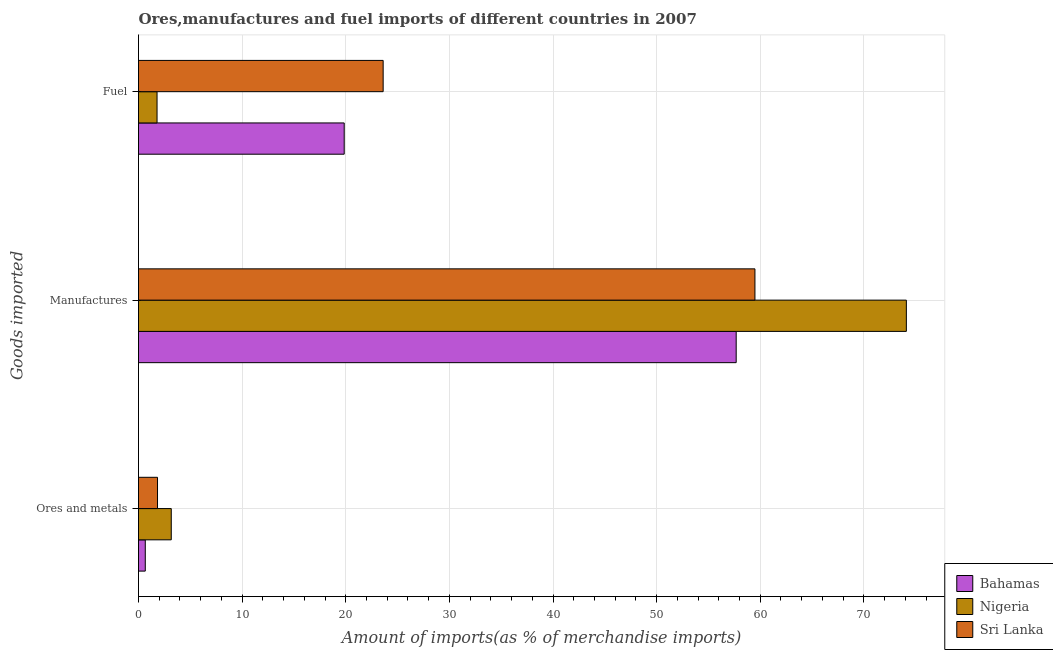How many different coloured bars are there?
Give a very brief answer. 3. Are the number of bars per tick equal to the number of legend labels?
Make the answer very short. Yes. Are the number of bars on each tick of the Y-axis equal?
Make the answer very short. Yes. How many bars are there on the 1st tick from the bottom?
Provide a succinct answer. 3. What is the label of the 1st group of bars from the top?
Make the answer very short. Fuel. What is the percentage of ores and metals imports in Nigeria?
Give a very brief answer. 3.16. Across all countries, what is the maximum percentage of manufactures imports?
Your answer should be compact. 74.1. Across all countries, what is the minimum percentage of fuel imports?
Offer a terse response. 1.79. In which country was the percentage of fuel imports maximum?
Your answer should be very brief. Sri Lanka. In which country was the percentage of fuel imports minimum?
Offer a very short reply. Nigeria. What is the total percentage of ores and metals imports in the graph?
Keep it short and to the point. 5.65. What is the difference between the percentage of ores and metals imports in Bahamas and that in Nigeria?
Your answer should be compact. -2.51. What is the difference between the percentage of manufactures imports in Sri Lanka and the percentage of fuel imports in Bahamas?
Your response must be concise. 39.64. What is the average percentage of manufactures imports per country?
Offer a terse response. 63.76. What is the difference between the percentage of manufactures imports and percentage of fuel imports in Sri Lanka?
Ensure brevity in your answer.  35.88. In how many countries, is the percentage of fuel imports greater than 60 %?
Offer a very short reply. 0. What is the ratio of the percentage of manufactures imports in Bahamas to that in Sri Lanka?
Make the answer very short. 0.97. Is the difference between the percentage of ores and metals imports in Sri Lanka and Bahamas greater than the difference between the percentage of fuel imports in Sri Lanka and Bahamas?
Give a very brief answer. No. What is the difference between the highest and the second highest percentage of ores and metals imports?
Give a very brief answer. 1.33. What is the difference between the highest and the lowest percentage of fuel imports?
Make the answer very short. 21.82. What does the 2nd bar from the top in Ores and metals represents?
Offer a terse response. Nigeria. What does the 2nd bar from the bottom in Ores and metals represents?
Ensure brevity in your answer.  Nigeria. Is it the case that in every country, the sum of the percentage of ores and metals imports and percentage of manufactures imports is greater than the percentage of fuel imports?
Offer a very short reply. Yes. How many bars are there?
Give a very brief answer. 9. Does the graph contain any zero values?
Offer a very short reply. No. Does the graph contain grids?
Ensure brevity in your answer.  Yes. Where does the legend appear in the graph?
Keep it short and to the point. Bottom right. How many legend labels are there?
Keep it short and to the point. 3. What is the title of the graph?
Your answer should be very brief. Ores,manufactures and fuel imports of different countries in 2007. What is the label or title of the X-axis?
Ensure brevity in your answer.  Amount of imports(as % of merchandise imports). What is the label or title of the Y-axis?
Your answer should be very brief. Goods imported. What is the Amount of imports(as % of merchandise imports) of Bahamas in Ores and metals?
Make the answer very short. 0.65. What is the Amount of imports(as % of merchandise imports) in Nigeria in Ores and metals?
Your answer should be compact. 3.16. What is the Amount of imports(as % of merchandise imports) in Sri Lanka in Ores and metals?
Keep it short and to the point. 1.83. What is the Amount of imports(as % of merchandise imports) in Bahamas in Manufactures?
Keep it short and to the point. 57.68. What is the Amount of imports(as % of merchandise imports) of Nigeria in Manufactures?
Ensure brevity in your answer.  74.1. What is the Amount of imports(as % of merchandise imports) in Sri Lanka in Manufactures?
Provide a short and direct response. 59.49. What is the Amount of imports(as % of merchandise imports) in Bahamas in Fuel?
Your response must be concise. 19.85. What is the Amount of imports(as % of merchandise imports) in Nigeria in Fuel?
Give a very brief answer. 1.79. What is the Amount of imports(as % of merchandise imports) in Sri Lanka in Fuel?
Give a very brief answer. 23.61. Across all Goods imported, what is the maximum Amount of imports(as % of merchandise imports) of Bahamas?
Provide a succinct answer. 57.68. Across all Goods imported, what is the maximum Amount of imports(as % of merchandise imports) of Nigeria?
Keep it short and to the point. 74.1. Across all Goods imported, what is the maximum Amount of imports(as % of merchandise imports) of Sri Lanka?
Offer a very short reply. 59.49. Across all Goods imported, what is the minimum Amount of imports(as % of merchandise imports) in Bahamas?
Offer a terse response. 0.65. Across all Goods imported, what is the minimum Amount of imports(as % of merchandise imports) of Nigeria?
Offer a very short reply. 1.79. Across all Goods imported, what is the minimum Amount of imports(as % of merchandise imports) in Sri Lanka?
Make the answer very short. 1.83. What is the total Amount of imports(as % of merchandise imports) in Bahamas in the graph?
Provide a succinct answer. 78.18. What is the total Amount of imports(as % of merchandise imports) of Nigeria in the graph?
Ensure brevity in your answer.  79.05. What is the total Amount of imports(as % of merchandise imports) of Sri Lanka in the graph?
Provide a short and direct response. 84.93. What is the difference between the Amount of imports(as % of merchandise imports) of Bahamas in Ores and metals and that in Manufactures?
Your answer should be very brief. -57.02. What is the difference between the Amount of imports(as % of merchandise imports) in Nigeria in Ores and metals and that in Manufactures?
Make the answer very short. -70.94. What is the difference between the Amount of imports(as % of merchandise imports) in Sri Lanka in Ores and metals and that in Manufactures?
Make the answer very short. -57.65. What is the difference between the Amount of imports(as % of merchandise imports) in Bahamas in Ores and metals and that in Fuel?
Your answer should be very brief. -19.2. What is the difference between the Amount of imports(as % of merchandise imports) in Nigeria in Ores and metals and that in Fuel?
Ensure brevity in your answer.  1.37. What is the difference between the Amount of imports(as % of merchandise imports) of Sri Lanka in Ores and metals and that in Fuel?
Offer a very short reply. -21.77. What is the difference between the Amount of imports(as % of merchandise imports) in Bahamas in Manufactures and that in Fuel?
Offer a very short reply. 37.83. What is the difference between the Amount of imports(as % of merchandise imports) of Nigeria in Manufactures and that in Fuel?
Your response must be concise. 72.31. What is the difference between the Amount of imports(as % of merchandise imports) of Sri Lanka in Manufactures and that in Fuel?
Provide a succinct answer. 35.88. What is the difference between the Amount of imports(as % of merchandise imports) of Bahamas in Ores and metals and the Amount of imports(as % of merchandise imports) of Nigeria in Manufactures?
Provide a succinct answer. -73.45. What is the difference between the Amount of imports(as % of merchandise imports) in Bahamas in Ores and metals and the Amount of imports(as % of merchandise imports) in Sri Lanka in Manufactures?
Keep it short and to the point. -58.83. What is the difference between the Amount of imports(as % of merchandise imports) of Nigeria in Ores and metals and the Amount of imports(as % of merchandise imports) of Sri Lanka in Manufactures?
Ensure brevity in your answer.  -56.33. What is the difference between the Amount of imports(as % of merchandise imports) in Bahamas in Ores and metals and the Amount of imports(as % of merchandise imports) in Nigeria in Fuel?
Your answer should be very brief. -1.14. What is the difference between the Amount of imports(as % of merchandise imports) of Bahamas in Ores and metals and the Amount of imports(as % of merchandise imports) of Sri Lanka in Fuel?
Make the answer very short. -22.95. What is the difference between the Amount of imports(as % of merchandise imports) in Nigeria in Ores and metals and the Amount of imports(as % of merchandise imports) in Sri Lanka in Fuel?
Keep it short and to the point. -20.45. What is the difference between the Amount of imports(as % of merchandise imports) in Bahamas in Manufactures and the Amount of imports(as % of merchandise imports) in Nigeria in Fuel?
Your answer should be compact. 55.89. What is the difference between the Amount of imports(as % of merchandise imports) in Bahamas in Manufactures and the Amount of imports(as % of merchandise imports) in Sri Lanka in Fuel?
Ensure brevity in your answer.  34.07. What is the difference between the Amount of imports(as % of merchandise imports) in Nigeria in Manufactures and the Amount of imports(as % of merchandise imports) in Sri Lanka in Fuel?
Offer a very short reply. 50.49. What is the average Amount of imports(as % of merchandise imports) in Bahamas per Goods imported?
Keep it short and to the point. 26.06. What is the average Amount of imports(as % of merchandise imports) of Nigeria per Goods imported?
Your answer should be very brief. 26.35. What is the average Amount of imports(as % of merchandise imports) in Sri Lanka per Goods imported?
Ensure brevity in your answer.  28.31. What is the difference between the Amount of imports(as % of merchandise imports) in Bahamas and Amount of imports(as % of merchandise imports) in Nigeria in Ores and metals?
Provide a short and direct response. -2.51. What is the difference between the Amount of imports(as % of merchandise imports) in Bahamas and Amount of imports(as % of merchandise imports) in Sri Lanka in Ores and metals?
Give a very brief answer. -1.18. What is the difference between the Amount of imports(as % of merchandise imports) in Nigeria and Amount of imports(as % of merchandise imports) in Sri Lanka in Ores and metals?
Give a very brief answer. 1.33. What is the difference between the Amount of imports(as % of merchandise imports) of Bahamas and Amount of imports(as % of merchandise imports) of Nigeria in Manufactures?
Ensure brevity in your answer.  -16.42. What is the difference between the Amount of imports(as % of merchandise imports) of Bahamas and Amount of imports(as % of merchandise imports) of Sri Lanka in Manufactures?
Provide a succinct answer. -1.81. What is the difference between the Amount of imports(as % of merchandise imports) in Nigeria and Amount of imports(as % of merchandise imports) in Sri Lanka in Manufactures?
Offer a terse response. 14.61. What is the difference between the Amount of imports(as % of merchandise imports) of Bahamas and Amount of imports(as % of merchandise imports) of Nigeria in Fuel?
Your answer should be very brief. 18.06. What is the difference between the Amount of imports(as % of merchandise imports) of Bahamas and Amount of imports(as % of merchandise imports) of Sri Lanka in Fuel?
Make the answer very short. -3.76. What is the difference between the Amount of imports(as % of merchandise imports) in Nigeria and Amount of imports(as % of merchandise imports) in Sri Lanka in Fuel?
Your answer should be compact. -21.82. What is the ratio of the Amount of imports(as % of merchandise imports) in Bahamas in Ores and metals to that in Manufactures?
Provide a short and direct response. 0.01. What is the ratio of the Amount of imports(as % of merchandise imports) in Nigeria in Ores and metals to that in Manufactures?
Offer a very short reply. 0.04. What is the ratio of the Amount of imports(as % of merchandise imports) in Sri Lanka in Ores and metals to that in Manufactures?
Make the answer very short. 0.03. What is the ratio of the Amount of imports(as % of merchandise imports) of Bahamas in Ores and metals to that in Fuel?
Provide a short and direct response. 0.03. What is the ratio of the Amount of imports(as % of merchandise imports) in Nigeria in Ores and metals to that in Fuel?
Ensure brevity in your answer.  1.77. What is the ratio of the Amount of imports(as % of merchandise imports) in Sri Lanka in Ores and metals to that in Fuel?
Give a very brief answer. 0.08. What is the ratio of the Amount of imports(as % of merchandise imports) in Bahamas in Manufactures to that in Fuel?
Offer a very short reply. 2.91. What is the ratio of the Amount of imports(as % of merchandise imports) in Nigeria in Manufactures to that in Fuel?
Keep it short and to the point. 41.4. What is the ratio of the Amount of imports(as % of merchandise imports) in Sri Lanka in Manufactures to that in Fuel?
Your answer should be compact. 2.52. What is the difference between the highest and the second highest Amount of imports(as % of merchandise imports) of Bahamas?
Keep it short and to the point. 37.83. What is the difference between the highest and the second highest Amount of imports(as % of merchandise imports) in Nigeria?
Give a very brief answer. 70.94. What is the difference between the highest and the second highest Amount of imports(as % of merchandise imports) of Sri Lanka?
Ensure brevity in your answer.  35.88. What is the difference between the highest and the lowest Amount of imports(as % of merchandise imports) in Bahamas?
Provide a short and direct response. 57.02. What is the difference between the highest and the lowest Amount of imports(as % of merchandise imports) in Nigeria?
Provide a succinct answer. 72.31. What is the difference between the highest and the lowest Amount of imports(as % of merchandise imports) in Sri Lanka?
Ensure brevity in your answer.  57.65. 